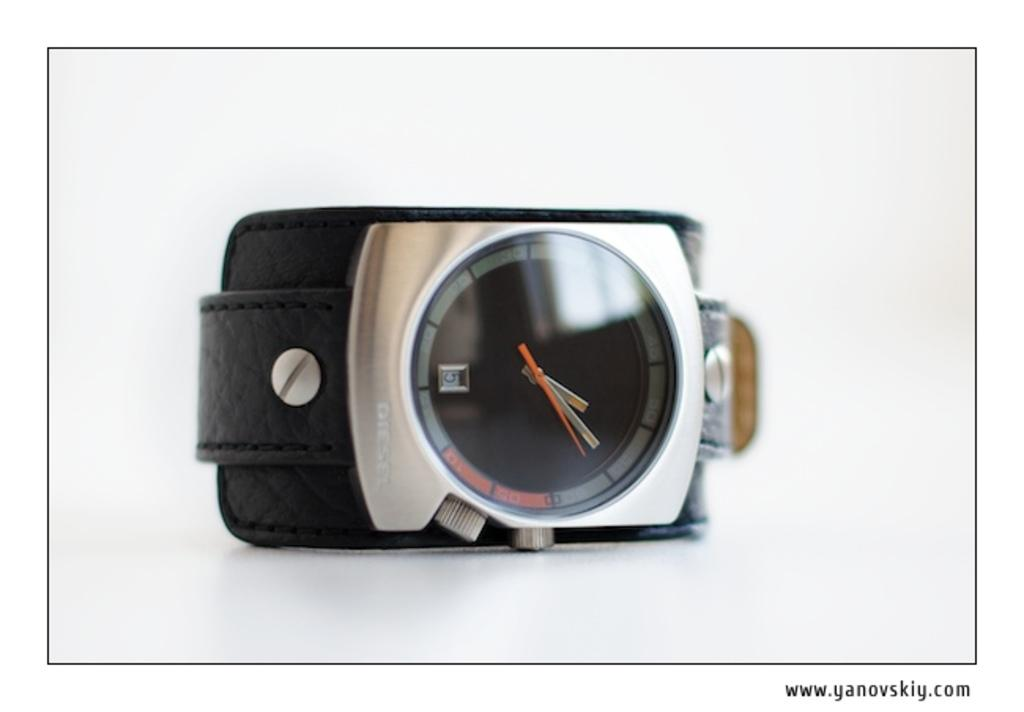Provide a one-sentence caption for the provided image. A Diesel wrist watch with a black band. 